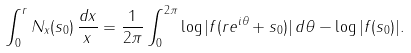<formula> <loc_0><loc_0><loc_500><loc_500>\int _ { 0 } ^ { r } N _ { x } ( s _ { 0 } ) \, \frac { d x } { x } = \frac { 1 } { 2 \pi } \int _ { 0 } ^ { 2 \pi } \log | f ( r e ^ { i \theta } + s _ { 0 } ) | \, d \theta - \log | f ( s _ { 0 } ) | .</formula> 